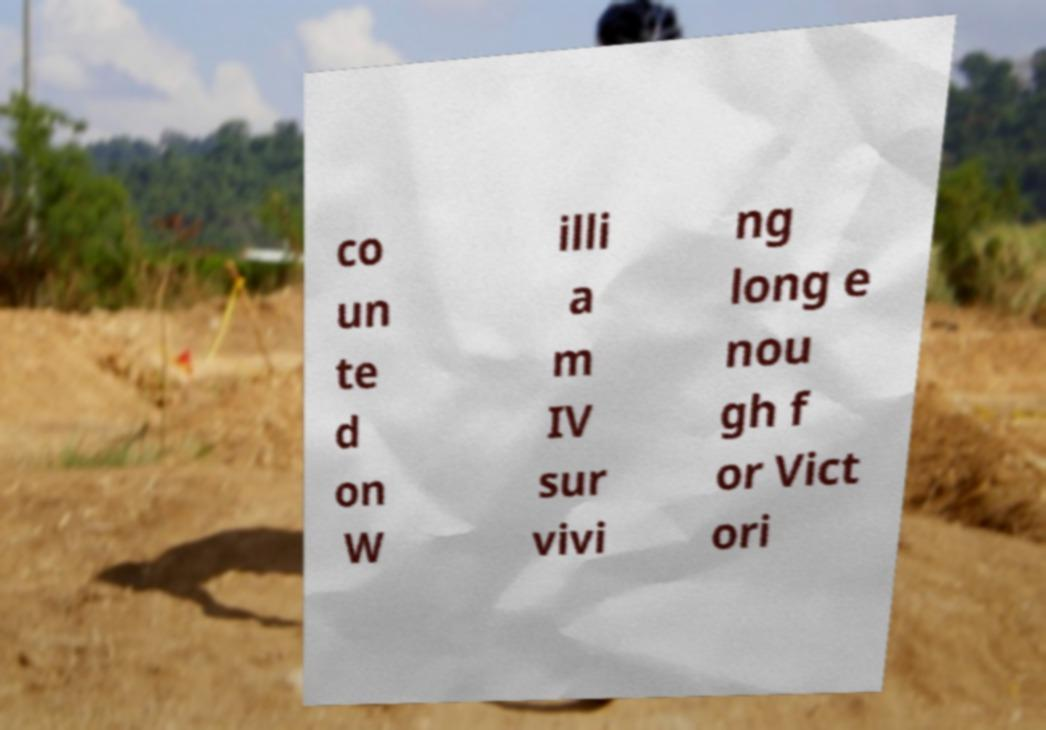Can you accurately transcribe the text from the provided image for me? co un te d on W illi a m IV sur vivi ng long e nou gh f or Vict ori 